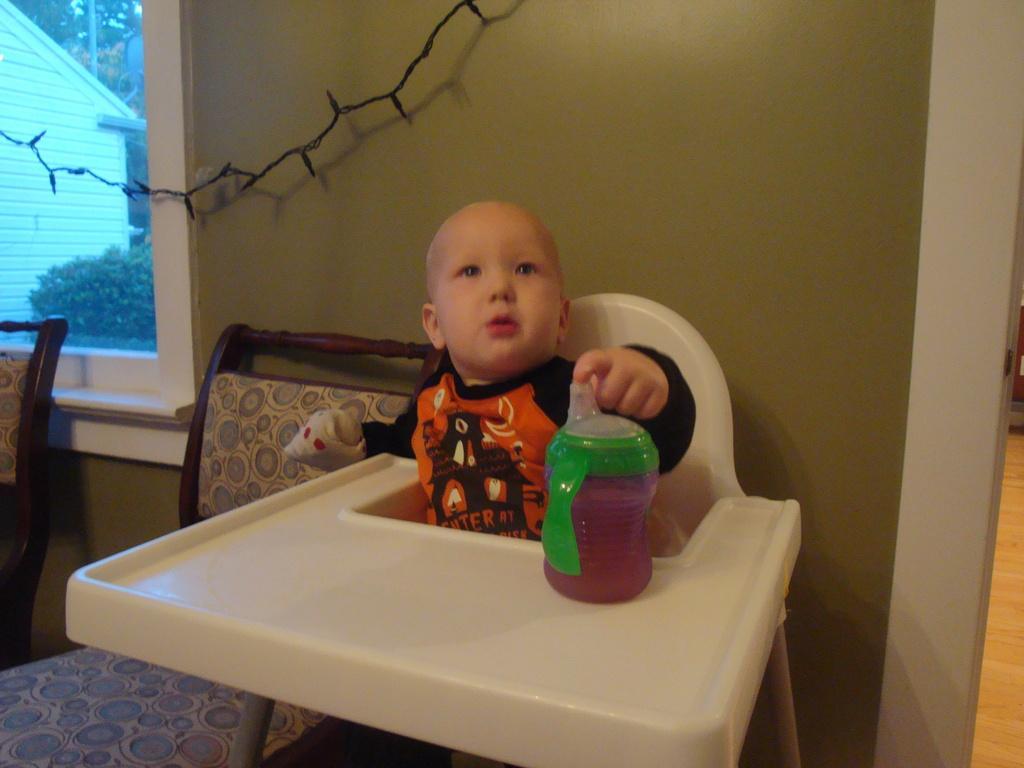Could you give a brief overview of what you see in this image? Baby is sitting on a chair. In-front of this baby there is a bottle. Outside of this window we can able to see a plants and house. Beside this baby there are 2 chairs. 